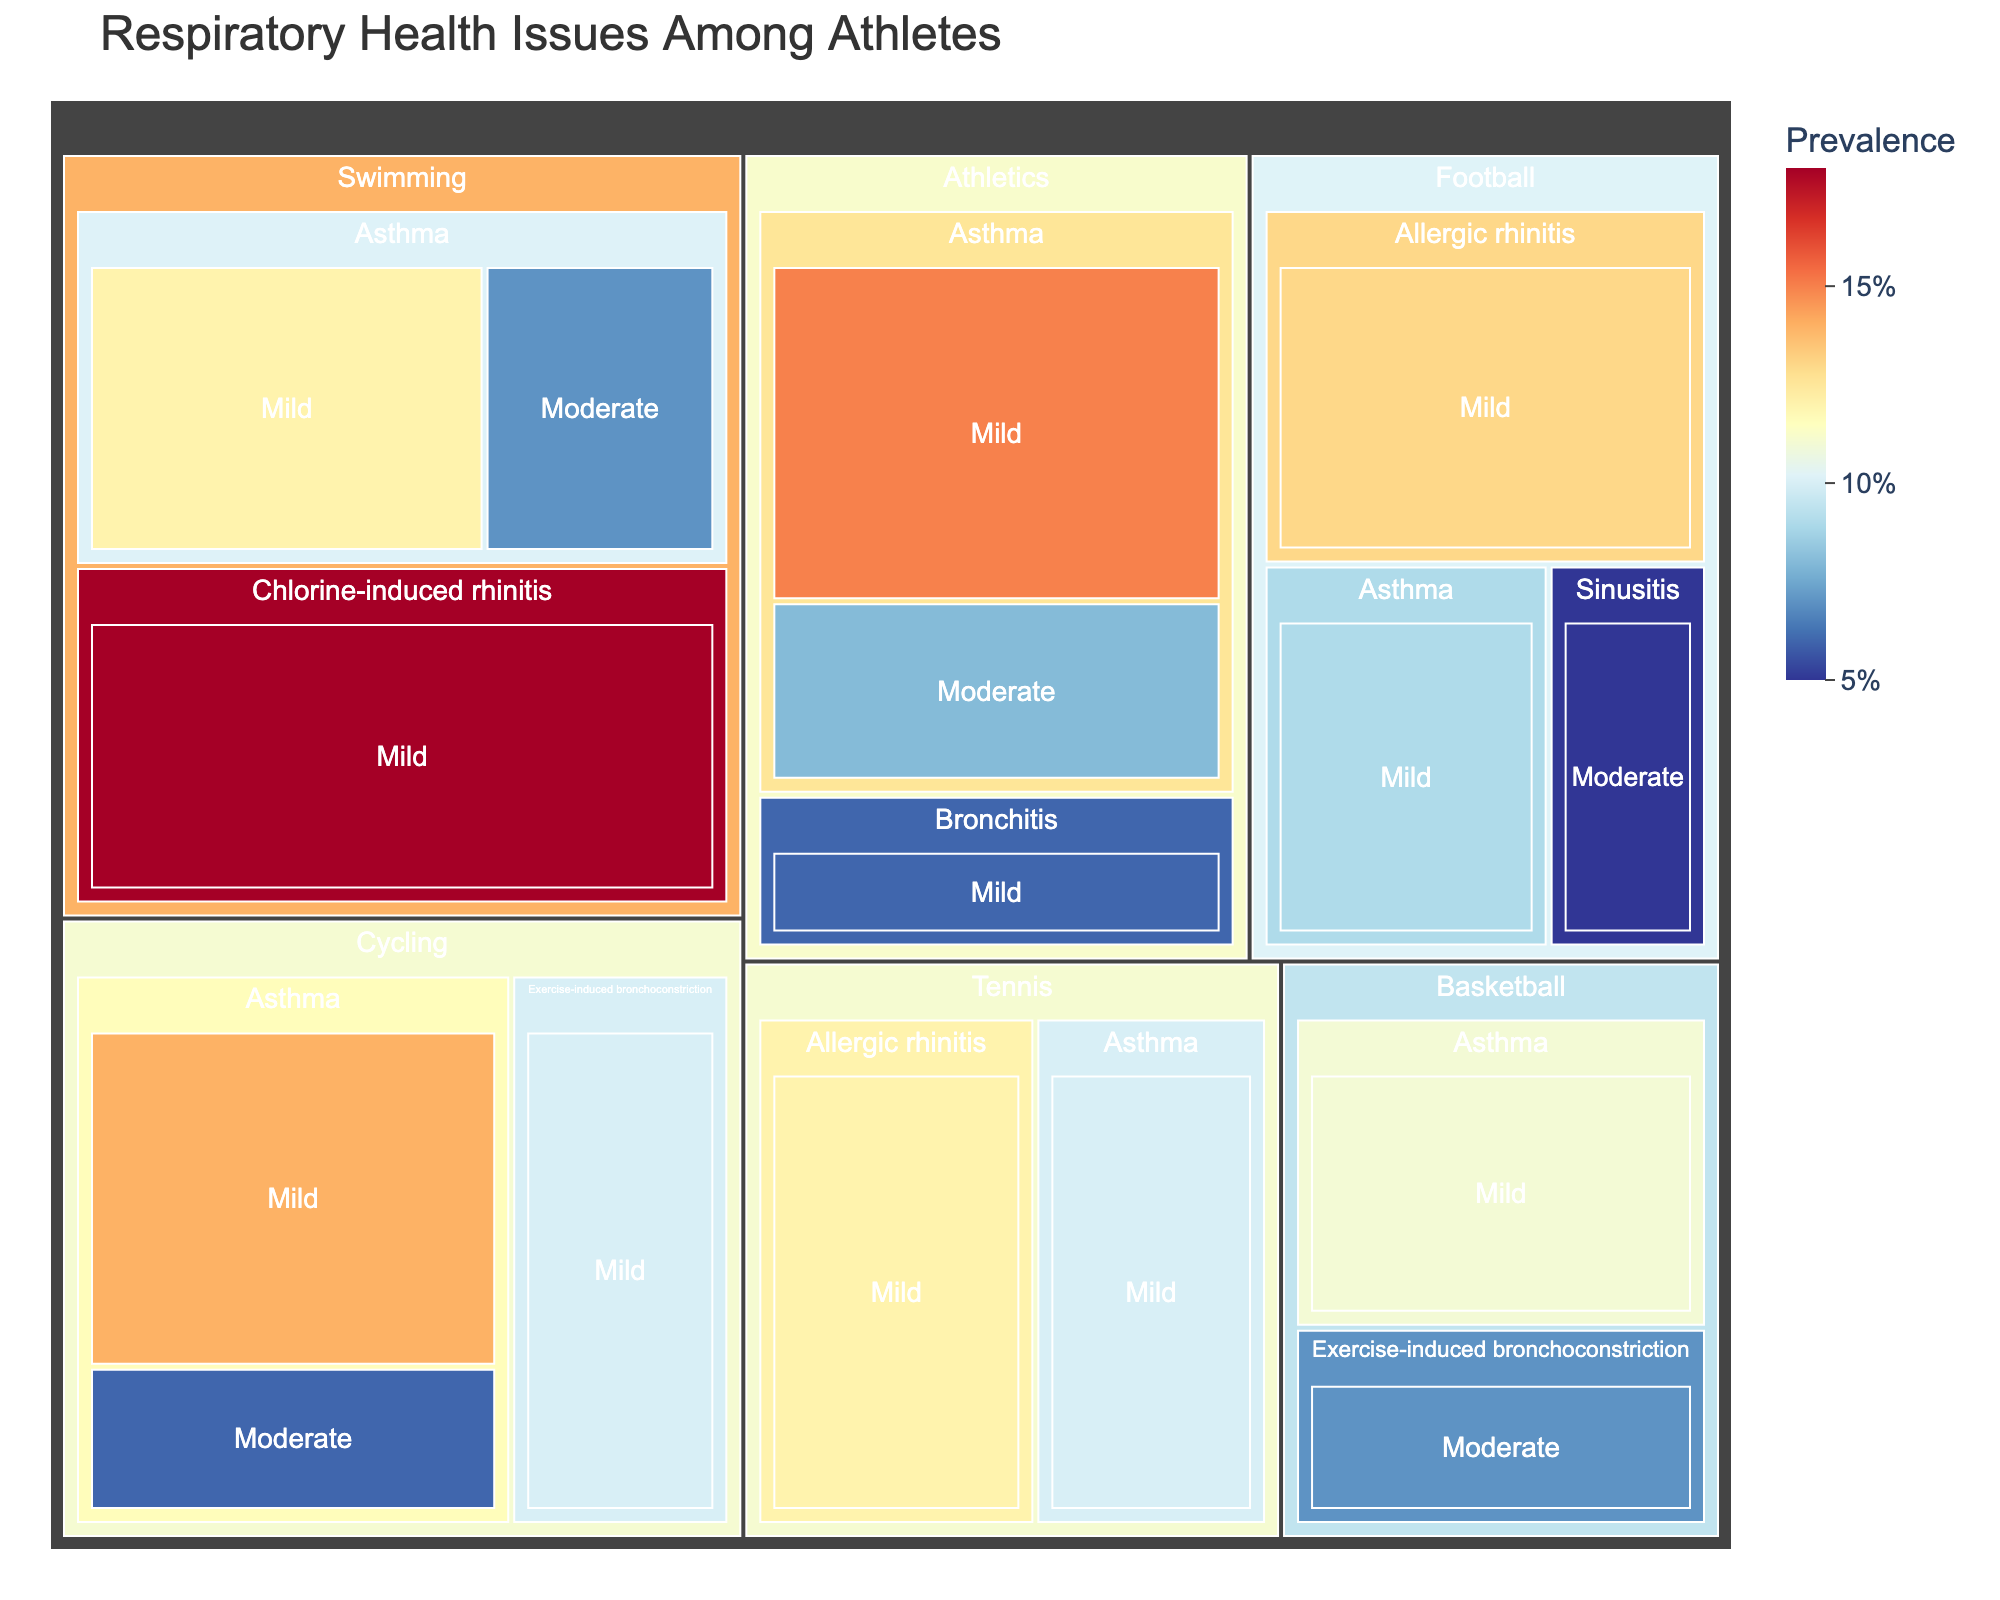what is the title of the treemap? The title is usually located at the top of the figure, providing a summary of what the figure represents. In this treemap, the title states the overall subject of the visualized data.
Answer: Respiratory Health Issues Among Athletes Which sport has the highest prevalence of mild asthma? From the tree structure, locate each sport and find the node labeled "Asthma" under the "Mild" severity category. Compare these values.
Answer: Athletics What is the combined prevalence of mild and moderate asthma in Swimming? Find the prevalence of mild and moderate asthma under Swimming and sum these values. 12 (Mild) + 7 (Moderate).
Answer: 19 Which condition and severity has the lowest prevalence in Football? Navigate the Football branch, then identify the condition and severity with the smallest value. In this case, look for the smallest prevalence percentage.
Answer: Sinusitis, Moderate How does the prevalence of chlorine-induced rhinitis in swimming compare to the prevalence of allergic rhinitis in Tennis? Locate both categories within their respective sports and compare their values. Chlorine-induced rhinitis in Swimming has 18% and Allergic rhinitis in Tennis has 12%.
Answer: Higher in Swimming What’s the total prevalence of respiratory health issues in Basketball? Sum up all prevalence percentages found under Basketball. Asthma (11%) + Exercise-induced bronchoconstriction (7%).
Answer: 18 Which sport shows the least variation in severity levels for asthma? Examine each sport's asthma prevalence by severity categories (mild and moderate) and assess the spread between the values. The smallest difference indicates the least variation.
Answer: Cycling How does the prevalence of exercise-induced bronchoconstriction in Basketball compare to its prevalence in Cycling? Compare the values for exercise-induced bronchoconstriction in both Basketball and Cycling. Basketball has 7% (Moderate), and Cycling has 10% (Mild).
Answer: Higher in Cycling Which condition has the highest prevalence value overall? Scan through all conditions under every sport and severity to find the maximum value displayed.
Answer: Chlorine-induced rhinitis, Mild (in Swimming) 